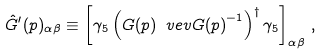Convert formula to latex. <formula><loc_0><loc_0><loc_500><loc_500>\hat { G } ^ { \prime } ( p ) _ { \alpha \beta } \equiv \left [ \gamma _ { 5 } \left ( G ( p ) \ v e v { G ( p ) } ^ { - 1 } \right ) ^ { \dagger } \gamma _ { 5 } \right ] _ { \alpha \beta } \, ,</formula> 